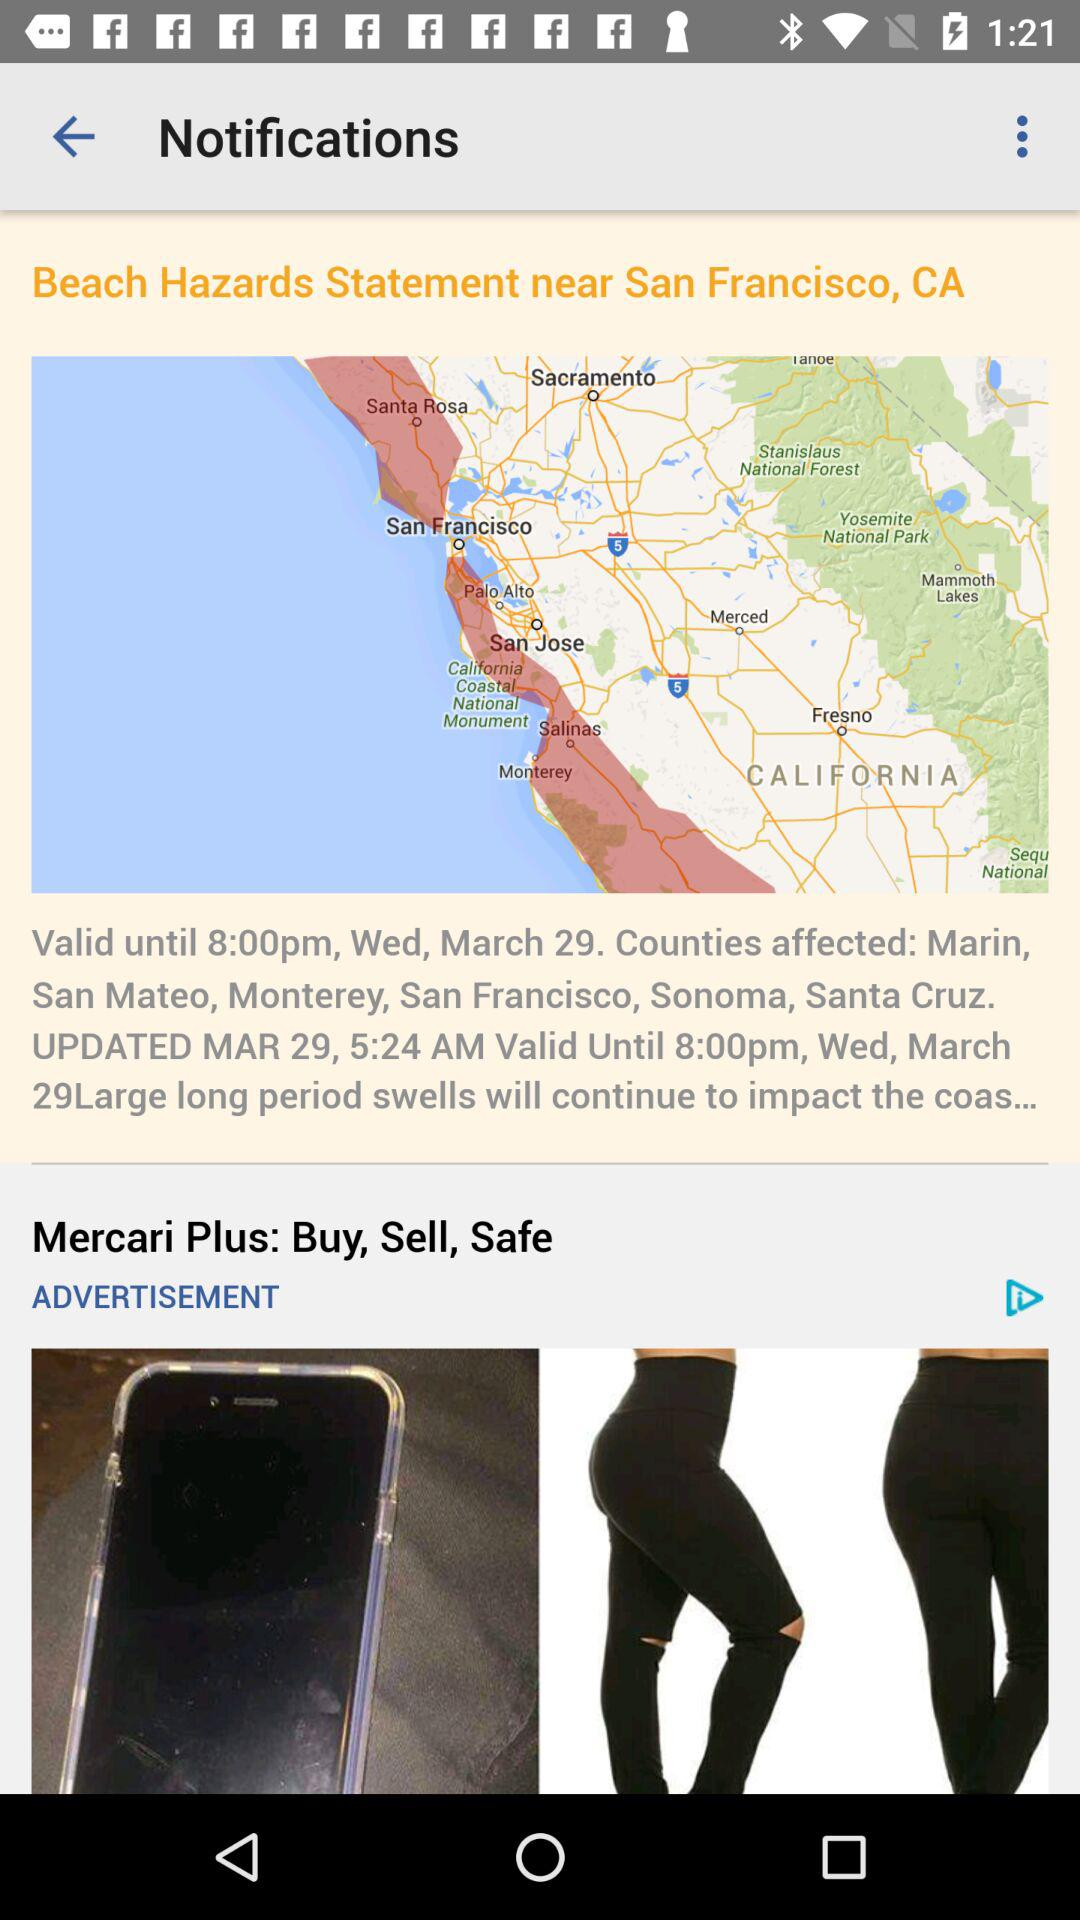Until what time is the notification valid? The notification is valid until 8:00 p.m. 